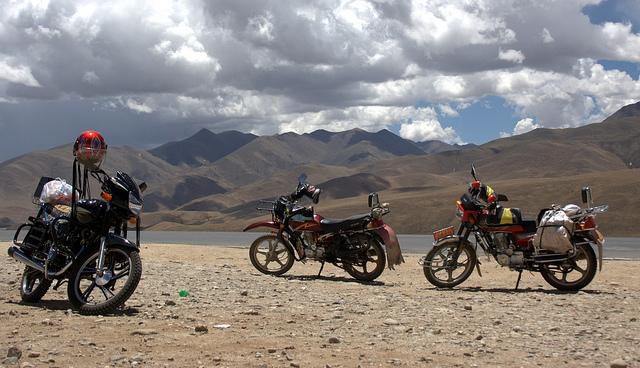Do you see a helmet?
Write a very short answer. Yes. Is this a desert?
Short answer required. Yes. How many motorcycles are there?
Write a very short answer. 3. How are the skies?
Keep it brief. Cloudy. Where are the bikes parked?
Give a very brief answer. Desert. 